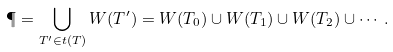Convert formula to latex. <formula><loc_0><loc_0><loc_500><loc_500>\P = \bigcup _ { T ^ { \prime } \in t ( T ) } W ( T ^ { \prime } ) = W ( T _ { 0 } ) \cup W ( T _ { 1 } ) \cup W ( T _ { 2 } ) \cup \cdots .</formula> 